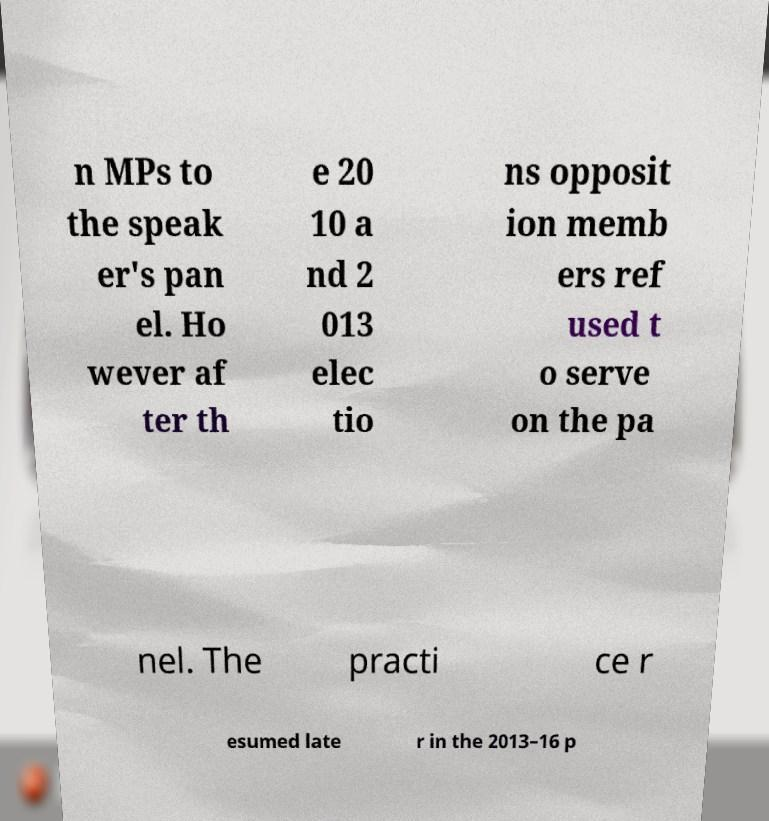Please read and relay the text visible in this image. What does it say? n MPs to the speak er's pan el. Ho wever af ter th e 20 10 a nd 2 013 elec tio ns opposit ion memb ers ref used t o serve on the pa nel. The practi ce r esumed late r in the 2013–16 p 